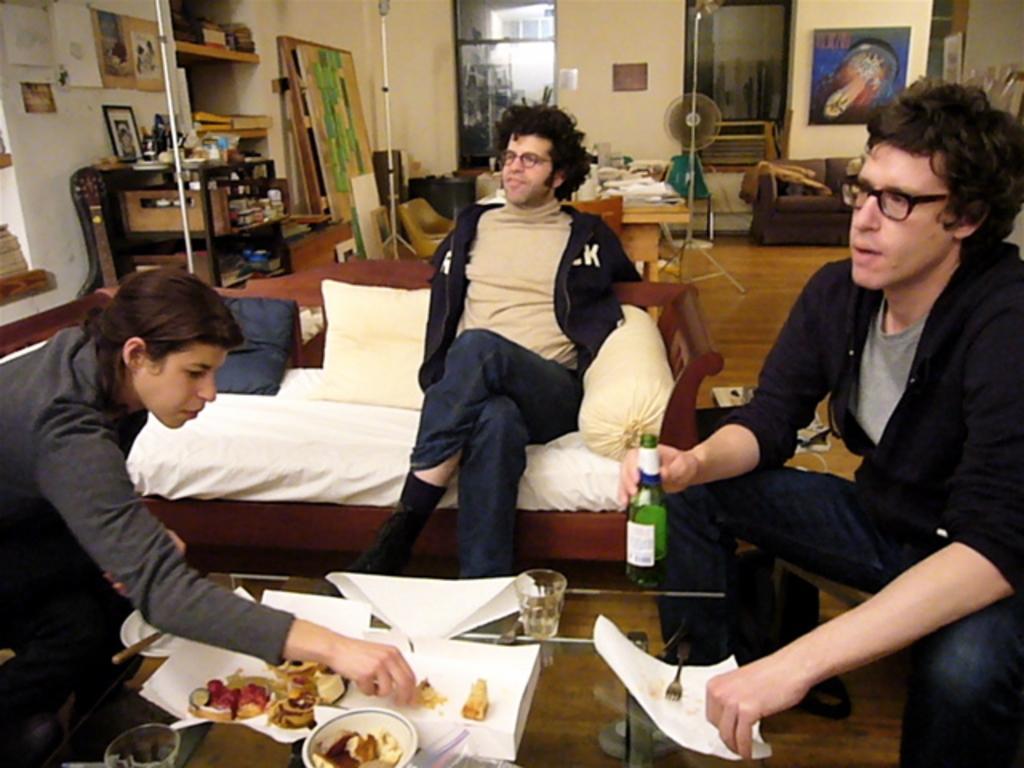How would you summarize this image in a sentence or two? In this image see can see some people sitting beside a table containing some food, papers, bowl, a glass and a fork on it. On the right side we can see a person holding a bottle and a paper. On the backside we can see a wall, pole, shelves, books, photo frames, windows, a couch and a table fan. 